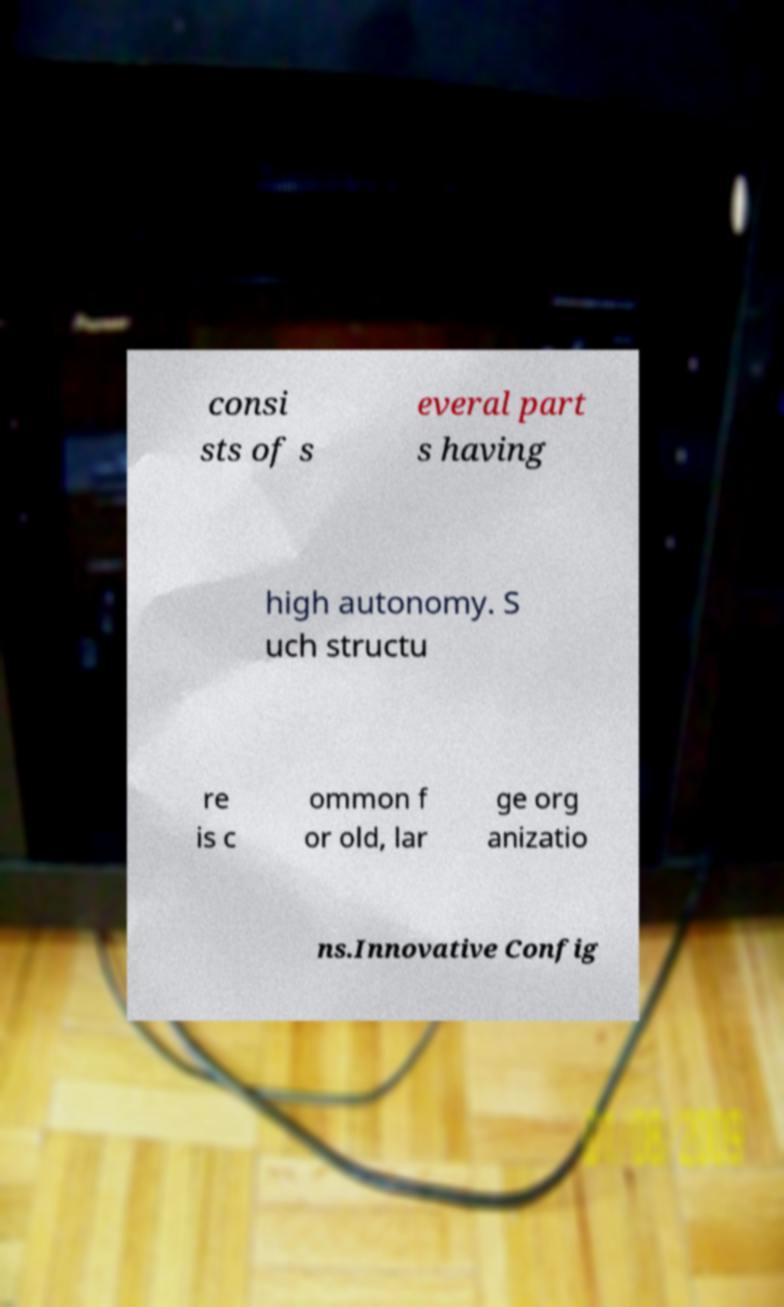For documentation purposes, I need the text within this image transcribed. Could you provide that? consi sts of s everal part s having high autonomy. S uch structu re is c ommon f or old, lar ge org anizatio ns.Innovative Config 